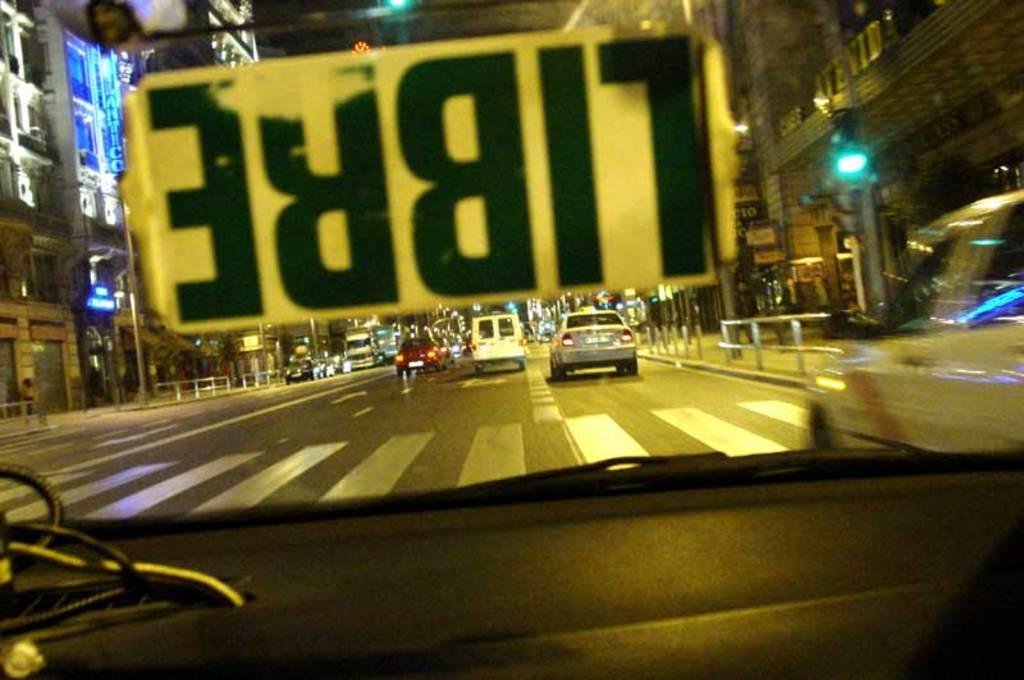Provide a one-sentence caption for the provided image. A car window has a sticker reading Libre on the windshield. 